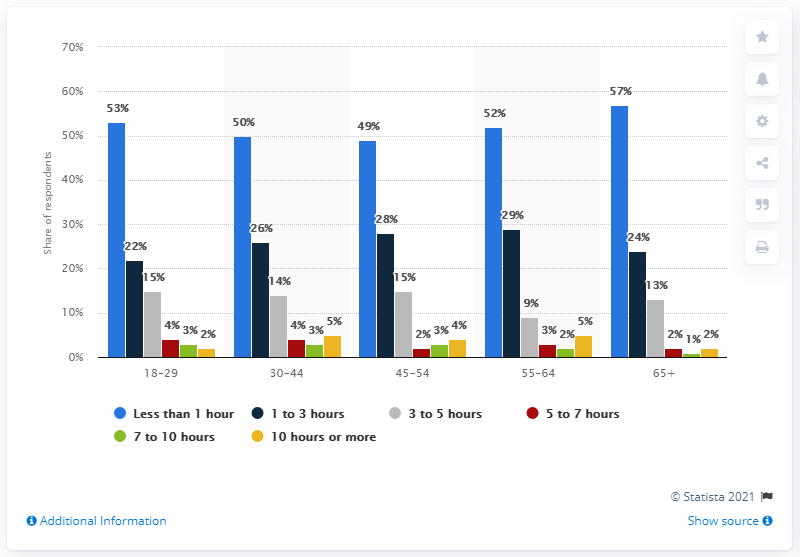Give some essential details in this illustration. On average, the total height of all red bars is 3. Six variables related to color were compared in the charts. 